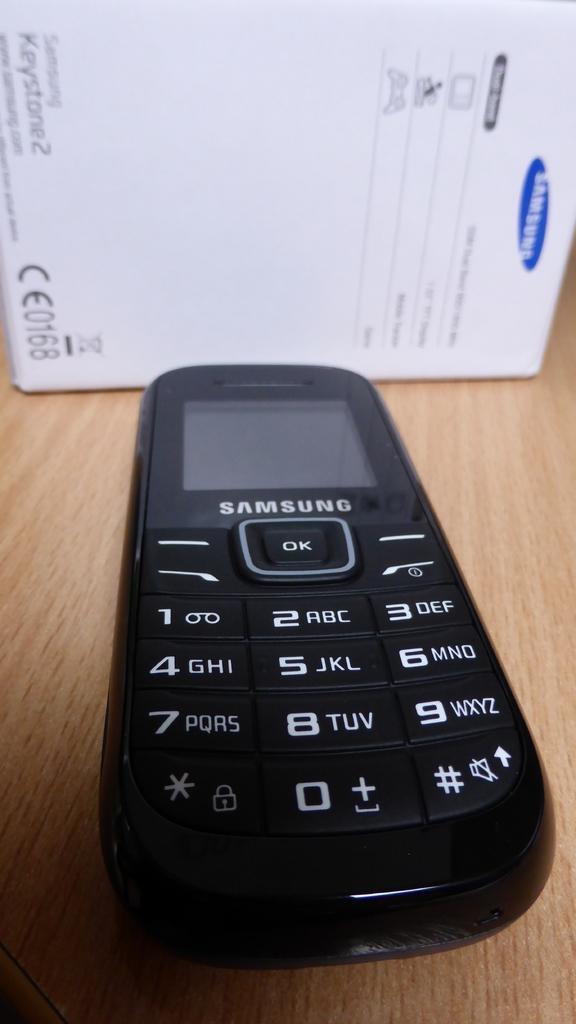In one or two sentences, can you explain what this image depicts? In this picture we can see a mobile phone here, in the background there is a white color box, at the bottom there is a wooden surface. 